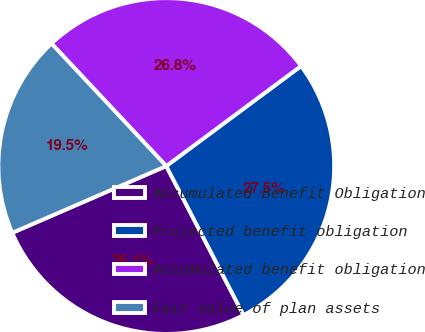Convert chart to OTSL. <chart><loc_0><loc_0><loc_500><loc_500><pie_chart><fcel>Accumulated Benefit Obligation<fcel>Projected benefit obligation<fcel>Accumulated benefit obligation<fcel>Fair value of plan assets<nl><fcel>26.1%<fcel>27.55%<fcel>26.82%<fcel>19.53%<nl></chart> 